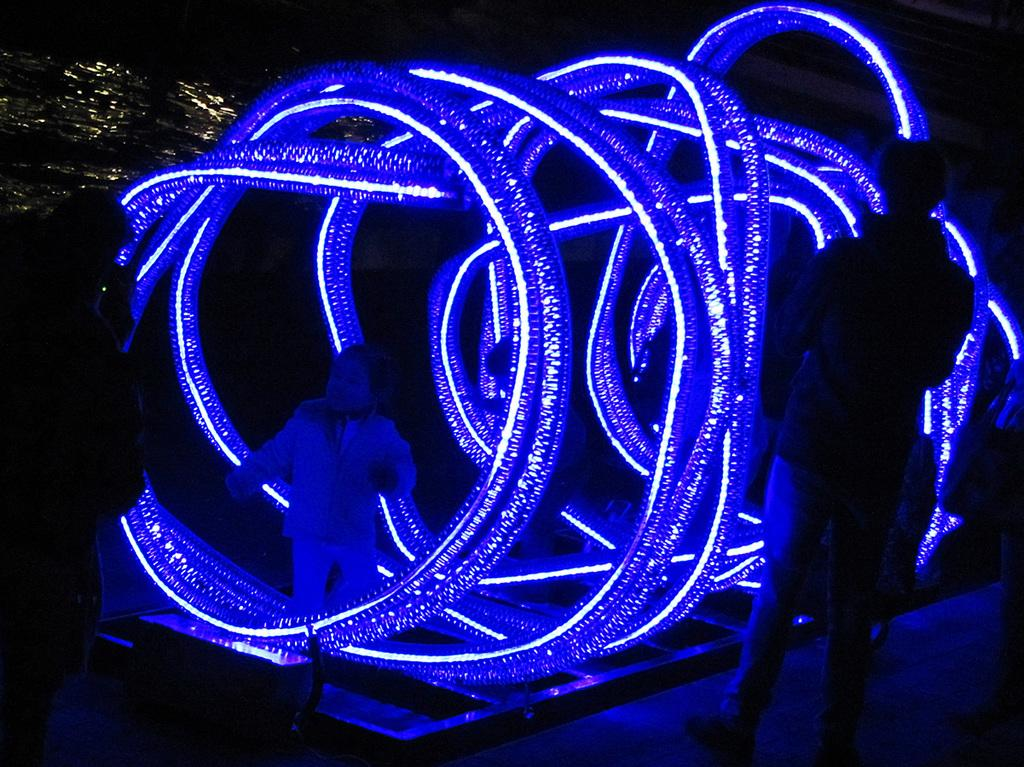Who or what can be seen in the image? There are people in the image. What type of lighting is present in the image? Decorative lights are visible in the image. How would you describe the background of the image? The background of the image is dark. What natural element is visible in the image? There is water visible in the image. How many ants can be seen crawling on the things in the image? There are no ants present in the image, and the term "things" is not specific enough to identify any objects. 